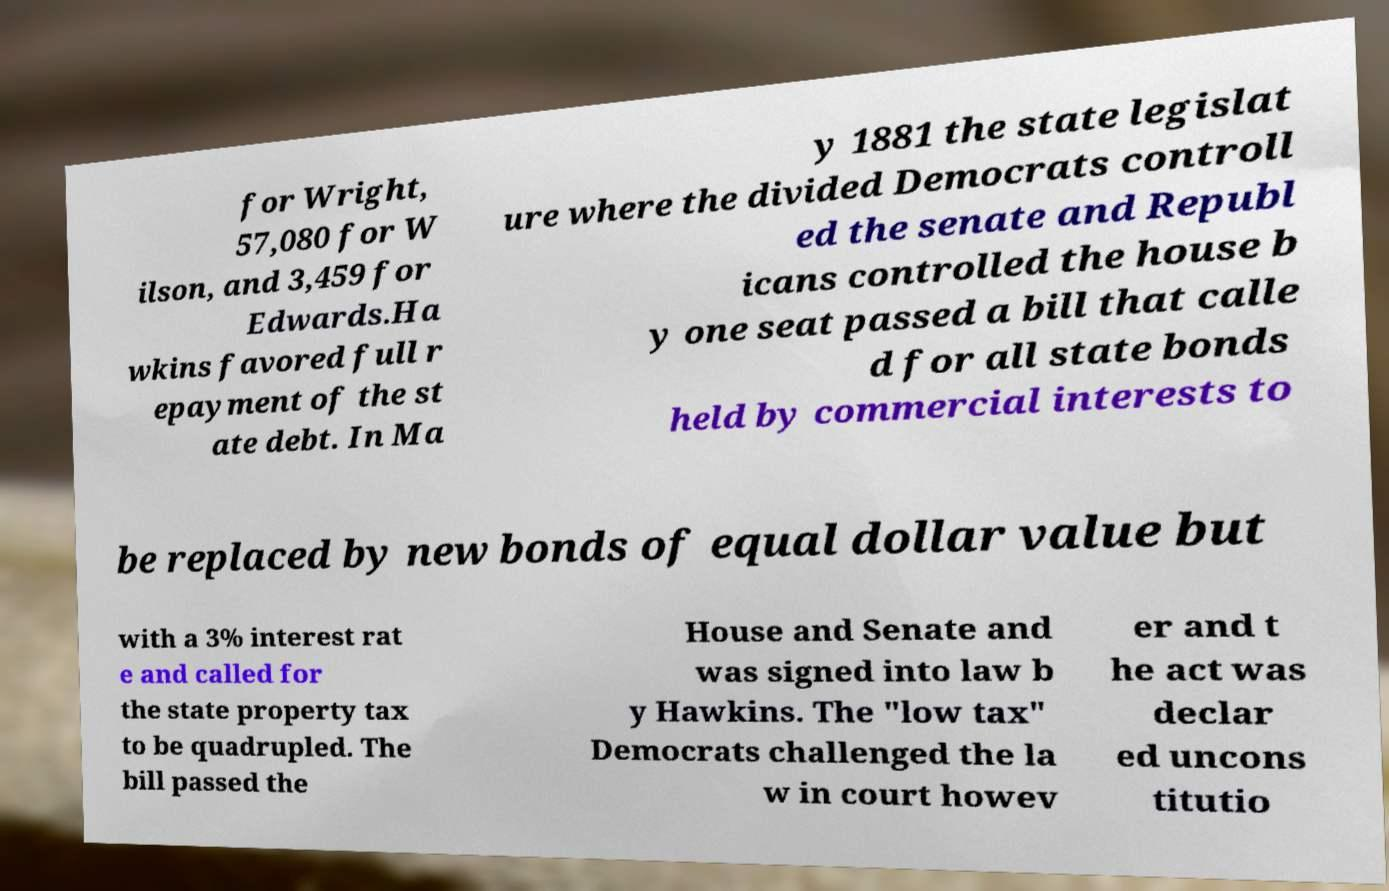There's text embedded in this image that I need extracted. Can you transcribe it verbatim? for Wright, 57,080 for W ilson, and 3,459 for Edwards.Ha wkins favored full r epayment of the st ate debt. In Ma y 1881 the state legislat ure where the divided Democrats controll ed the senate and Republ icans controlled the house b y one seat passed a bill that calle d for all state bonds held by commercial interests to be replaced by new bonds of equal dollar value but with a 3% interest rat e and called for the state property tax to be quadrupled. The bill passed the House and Senate and was signed into law b y Hawkins. The "low tax" Democrats challenged the la w in court howev er and t he act was declar ed uncons titutio 